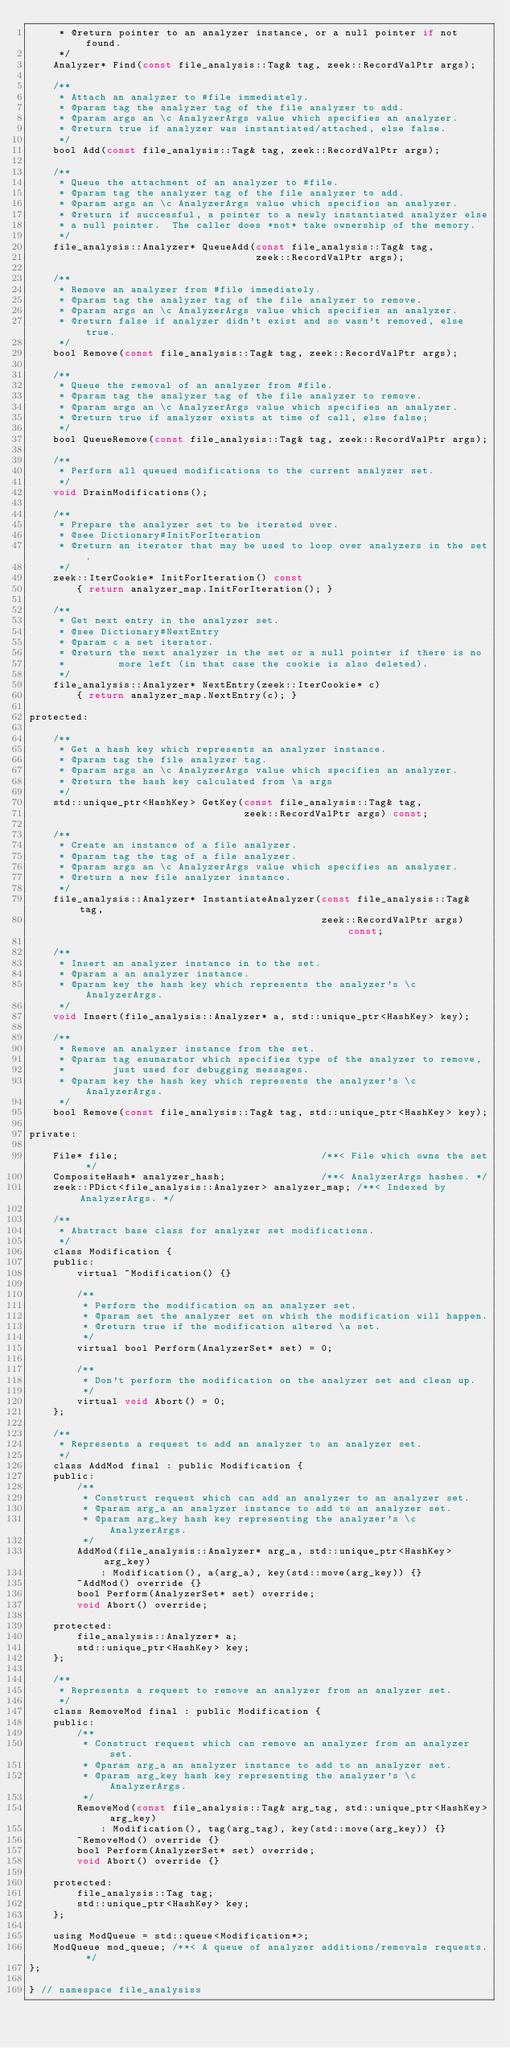Convert code to text. <code><loc_0><loc_0><loc_500><loc_500><_C_>	 * @return pointer to an analyzer instance, or a null pointer if not found.
	 */
	Analyzer* Find(const file_analysis::Tag& tag, zeek::RecordValPtr args);

	/**
	 * Attach an analyzer to #file immediately.
	 * @param tag the analyzer tag of the file analyzer to add.
	 * @param args an \c AnalyzerArgs value which specifies an analyzer.
	 * @return true if analyzer was instantiated/attached, else false.
	 */
	bool Add(const file_analysis::Tag& tag, zeek::RecordValPtr args);

	/**
	 * Queue the attachment of an analyzer to #file.
	 * @param tag the analyzer tag of the file analyzer to add.
	 * @param args an \c AnalyzerArgs value which specifies an analyzer.
	 * @return if successful, a pointer to a newly instantiated analyzer else
	 * a null pointer.  The caller does *not* take ownership of the memory.
	 */
	file_analysis::Analyzer* QueueAdd(const file_analysis::Tag& tag,
	                                  zeek::RecordValPtr args);

	/**
	 * Remove an analyzer from #file immediately.
	 * @param tag the analyzer tag of the file analyzer to remove.
	 * @param args an \c AnalyzerArgs value which specifies an analyzer.
	 * @return false if analyzer didn't exist and so wasn't removed, else true.
	 */
	bool Remove(const file_analysis::Tag& tag, zeek::RecordValPtr args);

	/**
	 * Queue the removal of an analyzer from #file.
	 * @param tag the analyzer tag of the file analyzer to remove.
	 * @param args an \c AnalyzerArgs value which specifies an analyzer.
	 * @return true if analyzer exists at time of call, else false;
	 */
	bool QueueRemove(const file_analysis::Tag& tag, zeek::RecordValPtr args);

	/**
	 * Perform all queued modifications to the current analyzer set.
	 */
	void DrainModifications();

	/**
	 * Prepare the analyzer set to be iterated over.
	 * @see Dictionary#InitForIteration
	 * @return an iterator that may be used to loop over analyzers in the set.
	 */
	zeek::IterCookie* InitForIteration() const
		{ return analyzer_map.InitForIteration(); }

	/**
	 * Get next entry in the analyzer set.
	 * @see Dictionary#NextEntry
	 * @param c a set iterator.
	 * @return the next analyzer in the set or a null pointer if there is no
	 *         more left (in that case the cookie is also deleted).
	 */
	file_analysis::Analyzer* NextEntry(zeek::IterCookie* c)
		{ return analyzer_map.NextEntry(c); }

protected:

	/**
	 * Get a hash key which represents an analyzer instance.
	 * @param tag the file analyzer tag.
	 * @param args an \c AnalyzerArgs value which specifies an analyzer.
	 * @return the hash key calculated from \a args
	 */
	std::unique_ptr<HashKey> GetKey(const file_analysis::Tag& tag,
	                                zeek::RecordValPtr args) const;

	/**
	 * Create an instance of a file analyzer.
	 * @param tag the tag of a file analyzer.
	 * @param args an \c AnalyzerArgs value which specifies an analyzer.
	 * @return a new file analyzer instance.
	 */
	file_analysis::Analyzer* InstantiateAnalyzer(const file_analysis::Tag& tag,
	                                             zeek::RecordValPtr args) const;

	/**
	 * Insert an analyzer instance in to the set.
	 * @param a an analyzer instance.
	 * @param key the hash key which represents the analyzer's \c AnalyzerArgs.
	 */
	void Insert(file_analysis::Analyzer* a, std::unique_ptr<HashKey> key);

	/**
	 * Remove an analyzer instance from the set.
	 * @param tag enumarator which specifies type of the analyzer to remove,
	 *        just used for debugging messages.
	 * @param key the hash key which represents the analyzer's \c AnalyzerArgs.
	 */
	bool Remove(const file_analysis::Tag& tag, std::unique_ptr<HashKey> key);

private:

	File* file;                                  /**< File which owns the set */
	CompositeHash* analyzer_hash;                /**< AnalyzerArgs hashes. */
	zeek::PDict<file_analysis::Analyzer> analyzer_map; /**< Indexed by AnalyzerArgs. */

	/**
	 * Abstract base class for analyzer set modifications.
	 */
	class Modification {
	public:
		virtual ~Modification() {}

		/**
		 * Perform the modification on an analyzer set.
		 * @param set the analyzer set on which the modification will happen.
		 * @return true if the modification altered \a set.
		 */
		virtual bool Perform(AnalyzerSet* set) = 0;

		/**
		 * Don't perform the modification on the analyzer set and clean up.
		 */
		virtual void Abort() = 0;
	};

	/**
	 * Represents a request to add an analyzer to an analyzer set.
	 */
	class AddMod final : public Modification {
	public:
		/**
		 * Construct request which can add an analyzer to an analyzer set.
		 * @param arg_a an analyzer instance to add to an analyzer set.
		 * @param arg_key hash key representing the analyzer's \c AnalyzerArgs.
		 */
		AddMod(file_analysis::Analyzer* arg_a, std::unique_ptr<HashKey> arg_key)
			: Modification(), a(arg_a), key(std::move(arg_key)) {}
		~AddMod() override {}
		bool Perform(AnalyzerSet* set) override;
		void Abort() override;

	protected:
		file_analysis::Analyzer* a;
		std::unique_ptr<HashKey> key;
	};

	/**
	 * Represents a request to remove an analyzer from an analyzer set.
	 */
	class RemoveMod final : public Modification {
	public:
		/**
		 * Construct request which can remove an analyzer from an analyzer set.
		 * @param arg_a an analyzer instance to add to an analyzer set.
		 * @param arg_key hash key representing the analyzer's \c AnalyzerArgs.
		 */
		RemoveMod(const file_analysis::Tag& arg_tag, std::unique_ptr<HashKey> arg_key)
			: Modification(), tag(arg_tag), key(std::move(arg_key)) {}
		~RemoveMod() override {}
		bool Perform(AnalyzerSet* set) override;
		void Abort() override {}

	protected:
		file_analysis::Tag tag;
		std::unique_ptr<HashKey> key;
	};

	using ModQueue = std::queue<Modification*>;
	ModQueue mod_queue;	/**< A queue of analyzer additions/removals requests. */
};

} // namespace file_analysiss
</code> 